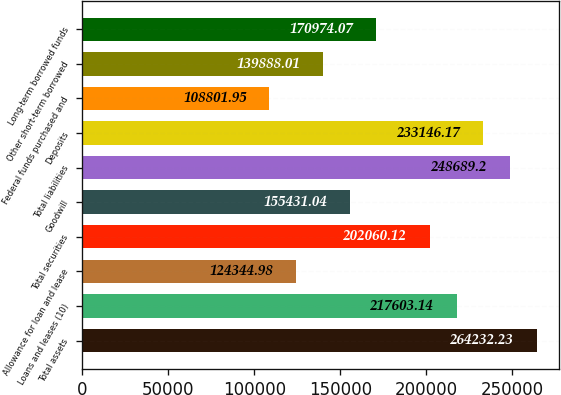Convert chart to OTSL. <chart><loc_0><loc_0><loc_500><loc_500><bar_chart><fcel>Total assets<fcel>Loans and leases (10)<fcel>Allowance for loan and lease<fcel>Total securities<fcel>Goodwill<fcel>Total liabilities<fcel>Deposits<fcel>Federal funds purchased and<fcel>Other short-term borrowed<fcel>Long-term borrowed funds<nl><fcel>264232<fcel>217603<fcel>124345<fcel>202060<fcel>155431<fcel>248689<fcel>233146<fcel>108802<fcel>139888<fcel>170974<nl></chart> 